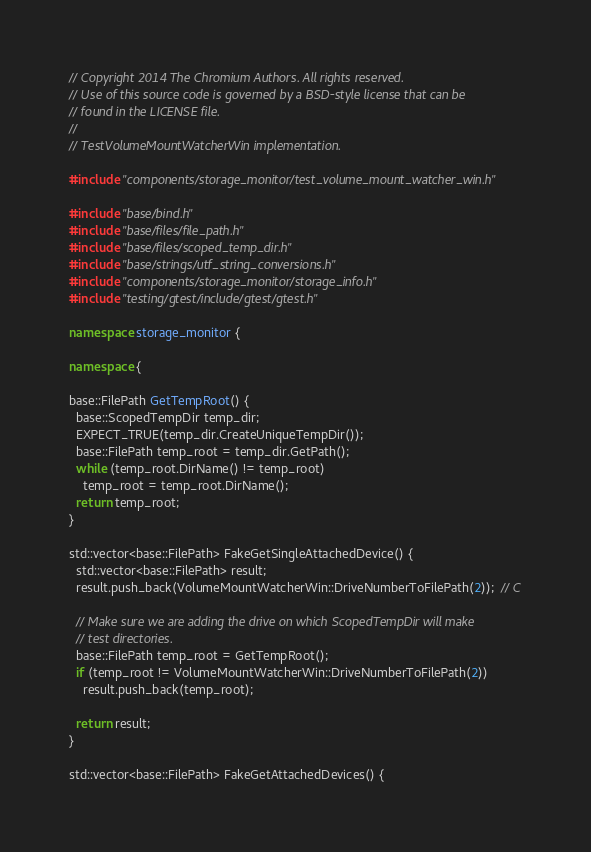Convert code to text. <code><loc_0><loc_0><loc_500><loc_500><_C++_>// Copyright 2014 The Chromium Authors. All rights reserved.
// Use of this source code is governed by a BSD-style license that can be
// found in the LICENSE file.
//
// TestVolumeMountWatcherWin implementation.

#include "components/storage_monitor/test_volume_mount_watcher_win.h"

#include "base/bind.h"
#include "base/files/file_path.h"
#include "base/files/scoped_temp_dir.h"
#include "base/strings/utf_string_conversions.h"
#include "components/storage_monitor/storage_info.h"
#include "testing/gtest/include/gtest/gtest.h"

namespace storage_monitor {

namespace {

base::FilePath GetTempRoot() {
  base::ScopedTempDir temp_dir;
  EXPECT_TRUE(temp_dir.CreateUniqueTempDir());
  base::FilePath temp_root = temp_dir.GetPath();
  while (temp_root.DirName() != temp_root)
    temp_root = temp_root.DirName();
  return temp_root;
}

std::vector<base::FilePath> FakeGetSingleAttachedDevice() {
  std::vector<base::FilePath> result;
  result.push_back(VolumeMountWatcherWin::DriveNumberToFilePath(2));  // C

  // Make sure we are adding the drive on which ScopedTempDir will make
  // test directories.
  base::FilePath temp_root = GetTempRoot();
  if (temp_root != VolumeMountWatcherWin::DriveNumberToFilePath(2))
    result.push_back(temp_root);

  return result;
}

std::vector<base::FilePath> FakeGetAttachedDevices() {</code> 